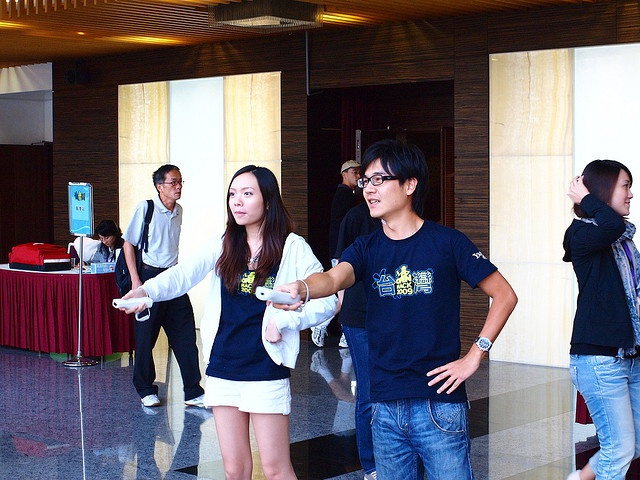Describe the objects in this image and their specific colors. I can see people in maroon, navy, black, blue, and lightpink tones, people in maroon, white, black, navy, and lightpink tones, people in maroon, black, and lightblue tones, people in maroon, black, white, lightblue, and darkgray tones, and people in maroon, navy, black, darkblue, and blue tones in this image. 